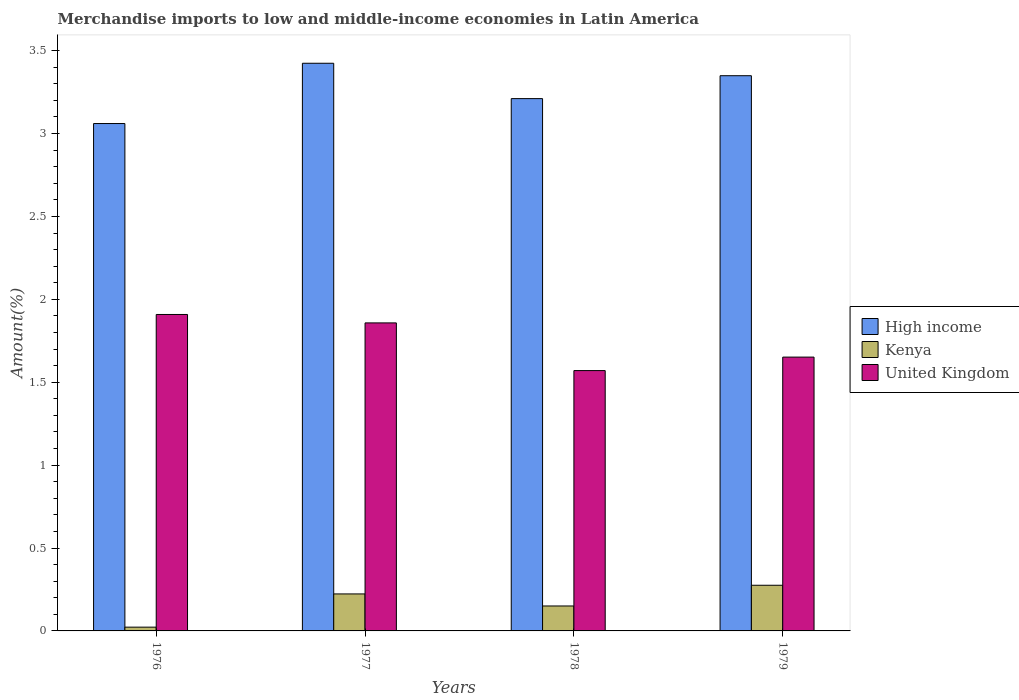How many different coloured bars are there?
Keep it short and to the point. 3. How many groups of bars are there?
Offer a terse response. 4. Are the number of bars per tick equal to the number of legend labels?
Give a very brief answer. Yes. Are the number of bars on each tick of the X-axis equal?
Your answer should be very brief. Yes. How many bars are there on the 4th tick from the right?
Your answer should be compact. 3. What is the label of the 3rd group of bars from the left?
Keep it short and to the point. 1978. In how many cases, is the number of bars for a given year not equal to the number of legend labels?
Provide a succinct answer. 0. What is the percentage of amount earned from merchandise imports in Kenya in 1977?
Ensure brevity in your answer.  0.22. Across all years, what is the maximum percentage of amount earned from merchandise imports in High income?
Make the answer very short. 3.42. Across all years, what is the minimum percentage of amount earned from merchandise imports in United Kingdom?
Offer a terse response. 1.57. In which year was the percentage of amount earned from merchandise imports in High income maximum?
Offer a terse response. 1977. In which year was the percentage of amount earned from merchandise imports in United Kingdom minimum?
Keep it short and to the point. 1978. What is the total percentage of amount earned from merchandise imports in Kenya in the graph?
Provide a succinct answer. 0.67. What is the difference between the percentage of amount earned from merchandise imports in United Kingdom in 1976 and that in 1979?
Give a very brief answer. 0.26. What is the difference between the percentage of amount earned from merchandise imports in United Kingdom in 1976 and the percentage of amount earned from merchandise imports in High income in 1979?
Your response must be concise. -1.44. What is the average percentage of amount earned from merchandise imports in Kenya per year?
Provide a short and direct response. 0.17. In the year 1977, what is the difference between the percentage of amount earned from merchandise imports in United Kingdom and percentage of amount earned from merchandise imports in Kenya?
Your answer should be compact. 1.63. In how many years, is the percentage of amount earned from merchandise imports in United Kingdom greater than 2.2 %?
Provide a succinct answer. 0. What is the ratio of the percentage of amount earned from merchandise imports in Kenya in 1976 to that in 1979?
Offer a terse response. 0.08. Is the percentage of amount earned from merchandise imports in United Kingdom in 1976 less than that in 1977?
Give a very brief answer. No. What is the difference between the highest and the second highest percentage of amount earned from merchandise imports in Kenya?
Your answer should be compact. 0.05. What is the difference between the highest and the lowest percentage of amount earned from merchandise imports in United Kingdom?
Your response must be concise. 0.34. In how many years, is the percentage of amount earned from merchandise imports in Kenya greater than the average percentage of amount earned from merchandise imports in Kenya taken over all years?
Provide a short and direct response. 2. What does the 2nd bar from the left in 1977 represents?
Give a very brief answer. Kenya. Are all the bars in the graph horizontal?
Your answer should be very brief. No. How many years are there in the graph?
Keep it short and to the point. 4. Are the values on the major ticks of Y-axis written in scientific E-notation?
Provide a succinct answer. No. Does the graph contain any zero values?
Your response must be concise. No. Does the graph contain grids?
Keep it short and to the point. No. Where does the legend appear in the graph?
Keep it short and to the point. Center right. What is the title of the graph?
Provide a succinct answer. Merchandise imports to low and middle-income economies in Latin America. Does "Iraq" appear as one of the legend labels in the graph?
Your answer should be very brief. No. What is the label or title of the X-axis?
Give a very brief answer. Years. What is the label or title of the Y-axis?
Provide a succinct answer. Amount(%). What is the Amount(%) in High income in 1976?
Your answer should be very brief. 3.06. What is the Amount(%) of Kenya in 1976?
Ensure brevity in your answer.  0.02. What is the Amount(%) in United Kingdom in 1976?
Your answer should be compact. 1.91. What is the Amount(%) of High income in 1977?
Make the answer very short. 3.42. What is the Amount(%) of Kenya in 1977?
Make the answer very short. 0.22. What is the Amount(%) of United Kingdom in 1977?
Your response must be concise. 1.86. What is the Amount(%) of High income in 1978?
Offer a very short reply. 3.21. What is the Amount(%) of Kenya in 1978?
Offer a very short reply. 0.15. What is the Amount(%) in United Kingdom in 1978?
Provide a short and direct response. 1.57. What is the Amount(%) of High income in 1979?
Provide a short and direct response. 3.35. What is the Amount(%) in Kenya in 1979?
Provide a short and direct response. 0.28. What is the Amount(%) of United Kingdom in 1979?
Ensure brevity in your answer.  1.65. Across all years, what is the maximum Amount(%) of High income?
Your answer should be very brief. 3.42. Across all years, what is the maximum Amount(%) of Kenya?
Make the answer very short. 0.28. Across all years, what is the maximum Amount(%) of United Kingdom?
Offer a terse response. 1.91. Across all years, what is the minimum Amount(%) in High income?
Provide a short and direct response. 3.06. Across all years, what is the minimum Amount(%) in Kenya?
Offer a very short reply. 0.02. Across all years, what is the minimum Amount(%) of United Kingdom?
Give a very brief answer. 1.57. What is the total Amount(%) in High income in the graph?
Your answer should be very brief. 13.04. What is the total Amount(%) of Kenya in the graph?
Ensure brevity in your answer.  0.67. What is the total Amount(%) of United Kingdom in the graph?
Your answer should be very brief. 6.99. What is the difference between the Amount(%) of High income in 1976 and that in 1977?
Offer a very short reply. -0.36. What is the difference between the Amount(%) in Kenya in 1976 and that in 1977?
Give a very brief answer. -0.2. What is the difference between the Amount(%) in United Kingdom in 1976 and that in 1977?
Your response must be concise. 0.05. What is the difference between the Amount(%) in High income in 1976 and that in 1978?
Keep it short and to the point. -0.15. What is the difference between the Amount(%) in Kenya in 1976 and that in 1978?
Give a very brief answer. -0.13. What is the difference between the Amount(%) of United Kingdom in 1976 and that in 1978?
Your response must be concise. 0.34. What is the difference between the Amount(%) in High income in 1976 and that in 1979?
Give a very brief answer. -0.29. What is the difference between the Amount(%) in Kenya in 1976 and that in 1979?
Make the answer very short. -0.25. What is the difference between the Amount(%) of United Kingdom in 1976 and that in 1979?
Offer a terse response. 0.26. What is the difference between the Amount(%) of High income in 1977 and that in 1978?
Give a very brief answer. 0.21. What is the difference between the Amount(%) of Kenya in 1977 and that in 1978?
Offer a terse response. 0.07. What is the difference between the Amount(%) in United Kingdom in 1977 and that in 1978?
Provide a short and direct response. 0.29. What is the difference between the Amount(%) in High income in 1977 and that in 1979?
Make the answer very short. 0.08. What is the difference between the Amount(%) in Kenya in 1977 and that in 1979?
Your answer should be very brief. -0.05. What is the difference between the Amount(%) of United Kingdom in 1977 and that in 1979?
Your answer should be compact. 0.21. What is the difference between the Amount(%) of High income in 1978 and that in 1979?
Ensure brevity in your answer.  -0.14. What is the difference between the Amount(%) of Kenya in 1978 and that in 1979?
Your response must be concise. -0.12. What is the difference between the Amount(%) of United Kingdom in 1978 and that in 1979?
Your answer should be very brief. -0.08. What is the difference between the Amount(%) of High income in 1976 and the Amount(%) of Kenya in 1977?
Offer a terse response. 2.84. What is the difference between the Amount(%) of High income in 1976 and the Amount(%) of United Kingdom in 1977?
Offer a very short reply. 1.2. What is the difference between the Amount(%) of Kenya in 1976 and the Amount(%) of United Kingdom in 1977?
Your answer should be very brief. -1.84. What is the difference between the Amount(%) in High income in 1976 and the Amount(%) in Kenya in 1978?
Ensure brevity in your answer.  2.91. What is the difference between the Amount(%) of High income in 1976 and the Amount(%) of United Kingdom in 1978?
Ensure brevity in your answer.  1.49. What is the difference between the Amount(%) in Kenya in 1976 and the Amount(%) in United Kingdom in 1978?
Your answer should be compact. -1.55. What is the difference between the Amount(%) of High income in 1976 and the Amount(%) of Kenya in 1979?
Provide a short and direct response. 2.78. What is the difference between the Amount(%) of High income in 1976 and the Amount(%) of United Kingdom in 1979?
Give a very brief answer. 1.41. What is the difference between the Amount(%) in Kenya in 1976 and the Amount(%) in United Kingdom in 1979?
Provide a succinct answer. -1.63. What is the difference between the Amount(%) of High income in 1977 and the Amount(%) of Kenya in 1978?
Make the answer very short. 3.27. What is the difference between the Amount(%) of High income in 1977 and the Amount(%) of United Kingdom in 1978?
Provide a succinct answer. 1.85. What is the difference between the Amount(%) of Kenya in 1977 and the Amount(%) of United Kingdom in 1978?
Offer a very short reply. -1.35. What is the difference between the Amount(%) of High income in 1977 and the Amount(%) of Kenya in 1979?
Your answer should be very brief. 3.15. What is the difference between the Amount(%) in High income in 1977 and the Amount(%) in United Kingdom in 1979?
Offer a very short reply. 1.77. What is the difference between the Amount(%) of Kenya in 1977 and the Amount(%) of United Kingdom in 1979?
Your response must be concise. -1.43. What is the difference between the Amount(%) in High income in 1978 and the Amount(%) in Kenya in 1979?
Offer a very short reply. 2.94. What is the difference between the Amount(%) of High income in 1978 and the Amount(%) of United Kingdom in 1979?
Ensure brevity in your answer.  1.56. What is the difference between the Amount(%) of Kenya in 1978 and the Amount(%) of United Kingdom in 1979?
Ensure brevity in your answer.  -1.5. What is the average Amount(%) in High income per year?
Your response must be concise. 3.26. What is the average Amount(%) in Kenya per year?
Give a very brief answer. 0.17. What is the average Amount(%) in United Kingdom per year?
Keep it short and to the point. 1.75. In the year 1976, what is the difference between the Amount(%) of High income and Amount(%) of Kenya?
Keep it short and to the point. 3.04. In the year 1976, what is the difference between the Amount(%) in High income and Amount(%) in United Kingdom?
Your response must be concise. 1.15. In the year 1976, what is the difference between the Amount(%) of Kenya and Amount(%) of United Kingdom?
Make the answer very short. -1.89. In the year 1977, what is the difference between the Amount(%) in High income and Amount(%) in Kenya?
Offer a terse response. 3.2. In the year 1977, what is the difference between the Amount(%) in High income and Amount(%) in United Kingdom?
Provide a succinct answer. 1.57. In the year 1977, what is the difference between the Amount(%) of Kenya and Amount(%) of United Kingdom?
Keep it short and to the point. -1.63. In the year 1978, what is the difference between the Amount(%) of High income and Amount(%) of Kenya?
Your answer should be compact. 3.06. In the year 1978, what is the difference between the Amount(%) of High income and Amount(%) of United Kingdom?
Make the answer very short. 1.64. In the year 1978, what is the difference between the Amount(%) of Kenya and Amount(%) of United Kingdom?
Your answer should be compact. -1.42. In the year 1979, what is the difference between the Amount(%) in High income and Amount(%) in Kenya?
Provide a short and direct response. 3.07. In the year 1979, what is the difference between the Amount(%) of High income and Amount(%) of United Kingdom?
Provide a succinct answer. 1.7. In the year 1979, what is the difference between the Amount(%) in Kenya and Amount(%) in United Kingdom?
Make the answer very short. -1.38. What is the ratio of the Amount(%) in High income in 1976 to that in 1977?
Give a very brief answer. 0.89. What is the ratio of the Amount(%) in Kenya in 1976 to that in 1977?
Your answer should be very brief. 0.1. What is the ratio of the Amount(%) of United Kingdom in 1976 to that in 1977?
Offer a terse response. 1.03. What is the ratio of the Amount(%) in High income in 1976 to that in 1978?
Your answer should be compact. 0.95. What is the ratio of the Amount(%) in Kenya in 1976 to that in 1978?
Your response must be concise. 0.15. What is the ratio of the Amount(%) of United Kingdom in 1976 to that in 1978?
Make the answer very short. 1.22. What is the ratio of the Amount(%) of High income in 1976 to that in 1979?
Your answer should be very brief. 0.91. What is the ratio of the Amount(%) in Kenya in 1976 to that in 1979?
Provide a succinct answer. 0.08. What is the ratio of the Amount(%) of United Kingdom in 1976 to that in 1979?
Offer a very short reply. 1.16. What is the ratio of the Amount(%) of High income in 1977 to that in 1978?
Keep it short and to the point. 1.07. What is the ratio of the Amount(%) in Kenya in 1977 to that in 1978?
Make the answer very short. 1.48. What is the ratio of the Amount(%) in United Kingdom in 1977 to that in 1978?
Offer a terse response. 1.18. What is the ratio of the Amount(%) of High income in 1977 to that in 1979?
Ensure brevity in your answer.  1.02. What is the ratio of the Amount(%) in Kenya in 1977 to that in 1979?
Offer a terse response. 0.81. What is the ratio of the Amount(%) in United Kingdom in 1977 to that in 1979?
Provide a succinct answer. 1.12. What is the ratio of the Amount(%) of High income in 1978 to that in 1979?
Offer a very short reply. 0.96. What is the ratio of the Amount(%) of Kenya in 1978 to that in 1979?
Your response must be concise. 0.55. What is the ratio of the Amount(%) in United Kingdom in 1978 to that in 1979?
Your answer should be compact. 0.95. What is the difference between the highest and the second highest Amount(%) of High income?
Your answer should be compact. 0.08. What is the difference between the highest and the second highest Amount(%) of Kenya?
Ensure brevity in your answer.  0.05. What is the difference between the highest and the second highest Amount(%) of United Kingdom?
Your answer should be compact. 0.05. What is the difference between the highest and the lowest Amount(%) of High income?
Keep it short and to the point. 0.36. What is the difference between the highest and the lowest Amount(%) in Kenya?
Keep it short and to the point. 0.25. What is the difference between the highest and the lowest Amount(%) of United Kingdom?
Make the answer very short. 0.34. 